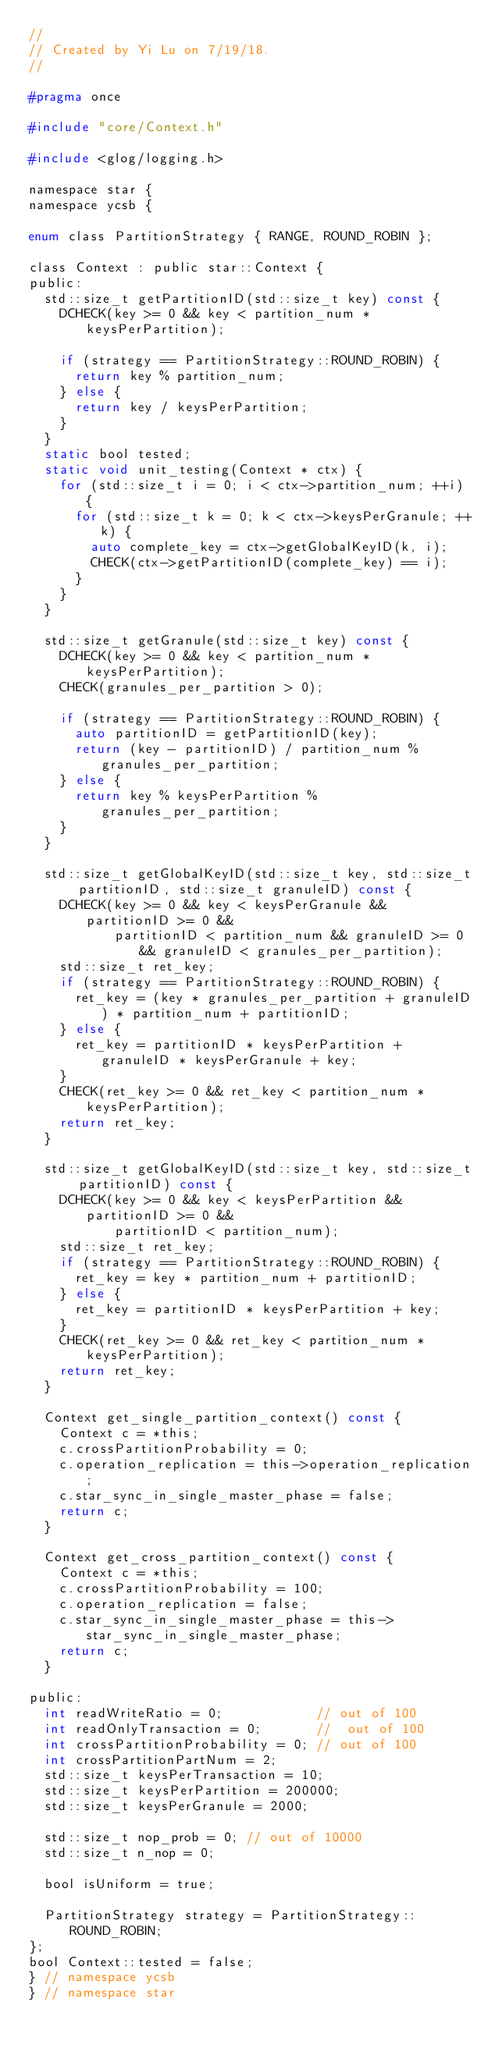<code> <loc_0><loc_0><loc_500><loc_500><_C_>//
// Created by Yi Lu on 7/19/18.
//

#pragma once

#include "core/Context.h"

#include <glog/logging.h>

namespace star {
namespace ycsb {

enum class PartitionStrategy { RANGE, ROUND_ROBIN };

class Context : public star::Context {
public:
  std::size_t getPartitionID(std::size_t key) const {
    DCHECK(key >= 0 && key < partition_num * keysPerPartition);

    if (strategy == PartitionStrategy::ROUND_ROBIN) {
      return key % partition_num;
    } else {
      return key / keysPerPartition;
    }
  }
  static bool tested;
  static void unit_testing(Context * ctx) {
    for (std::size_t i = 0; i < ctx->partition_num; ++i) {
      for (std::size_t k = 0; k < ctx->keysPerGranule; ++k) {
        auto complete_key = ctx->getGlobalKeyID(k, i);
        CHECK(ctx->getPartitionID(complete_key) == i);
      }
    }
  }

  std::size_t getGranule(std::size_t key) const {
    DCHECK(key >= 0 && key < partition_num * keysPerPartition);
    CHECK(granules_per_partition > 0);

    if (strategy == PartitionStrategy::ROUND_ROBIN) {
      auto partitionID = getPartitionID(key);
      return (key - partitionID) / partition_num % granules_per_partition;
    } else {
      return key % keysPerPartition % granules_per_partition;
    }
  }

  std::size_t getGlobalKeyID(std::size_t key, std::size_t partitionID, std::size_t granuleID) const {
    DCHECK(key >= 0 && key < keysPerGranule && partitionID >= 0 &&
           partitionID < partition_num && granuleID >= 0 && granuleID < granules_per_partition);
    std::size_t ret_key;
    if (strategy == PartitionStrategy::ROUND_ROBIN) {
      ret_key = (key * granules_per_partition + granuleID) * partition_num + partitionID;
    } else {
      ret_key = partitionID * keysPerPartition + granuleID * keysPerGranule + key;
    }
    CHECK(ret_key >= 0 && ret_key < partition_num * keysPerPartition);
    return ret_key;
  }

  std::size_t getGlobalKeyID(std::size_t key, std::size_t partitionID) const {
    DCHECK(key >= 0 && key < keysPerPartition && partitionID >= 0 &&
           partitionID < partition_num);
    std::size_t ret_key;
    if (strategy == PartitionStrategy::ROUND_ROBIN) {
      ret_key = key * partition_num + partitionID;
    } else {
      ret_key = partitionID * keysPerPartition + key;
    }
    CHECK(ret_key >= 0 && ret_key < partition_num * keysPerPartition);
    return ret_key;
  }

  Context get_single_partition_context() const {
    Context c = *this;
    c.crossPartitionProbability = 0;
    c.operation_replication = this->operation_replication;
    c.star_sync_in_single_master_phase = false;
    return c;
  }

  Context get_cross_partition_context() const {
    Context c = *this;
    c.crossPartitionProbability = 100;
    c.operation_replication = false;
    c.star_sync_in_single_master_phase = this->star_sync_in_single_master_phase;
    return c;
  }

public:
  int readWriteRatio = 0;            // out of 100
  int readOnlyTransaction = 0;       //  out of 100
  int crossPartitionProbability = 0; // out of 100
  int crossPartitionPartNum = 2;
  std::size_t keysPerTransaction = 10;
  std::size_t keysPerPartition = 200000;
  std::size_t keysPerGranule = 2000;

  std::size_t nop_prob = 0; // out of 10000
  std::size_t n_nop = 0;

  bool isUniform = true;

  PartitionStrategy strategy = PartitionStrategy::ROUND_ROBIN;
};
bool Context::tested = false;
} // namespace ycsb
} // namespace star
</code> 